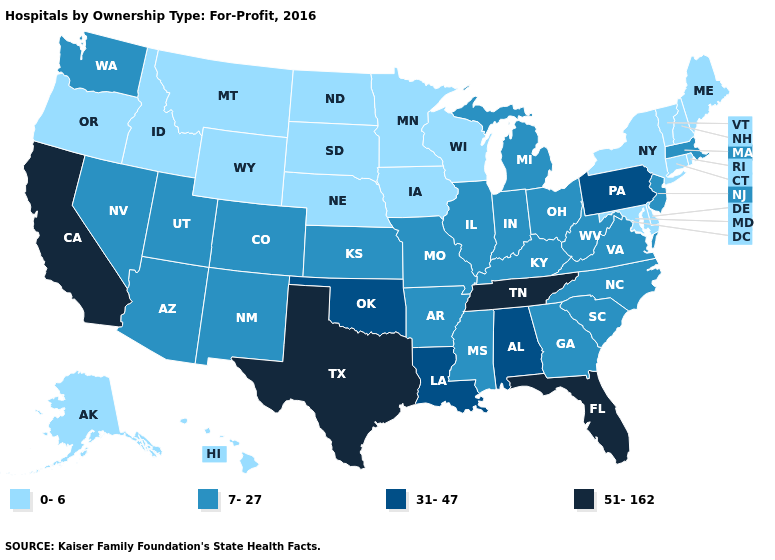Does the first symbol in the legend represent the smallest category?
Be succinct. Yes. Among the states that border Wyoming , does Colorado have the lowest value?
Concise answer only. No. What is the lowest value in the South?
Answer briefly. 0-6. What is the value of Mississippi?
Be succinct. 7-27. Which states have the lowest value in the USA?
Concise answer only. Alaska, Connecticut, Delaware, Hawaii, Idaho, Iowa, Maine, Maryland, Minnesota, Montana, Nebraska, New Hampshire, New York, North Dakota, Oregon, Rhode Island, South Dakota, Vermont, Wisconsin, Wyoming. Among the states that border Arkansas , does Mississippi have the highest value?
Keep it brief. No. What is the lowest value in the USA?
Concise answer only. 0-6. How many symbols are there in the legend?
Concise answer only. 4. What is the value of Connecticut?
Be succinct. 0-6. What is the value of Kansas?
Concise answer only. 7-27. Name the states that have a value in the range 7-27?
Keep it brief. Arizona, Arkansas, Colorado, Georgia, Illinois, Indiana, Kansas, Kentucky, Massachusetts, Michigan, Mississippi, Missouri, Nevada, New Jersey, New Mexico, North Carolina, Ohio, South Carolina, Utah, Virginia, Washington, West Virginia. What is the lowest value in the USA?
Keep it brief. 0-6. What is the value of Ohio?
Answer briefly. 7-27. Name the states that have a value in the range 0-6?
Concise answer only. Alaska, Connecticut, Delaware, Hawaii, Idaho, Iowa, Maine, Maryland, Minnesota, Montana, Nebraska, New Hampshire, New York, North Dakota, Oregon, Rhode Island, South Dakota, Vermont, Wisconsin, Wyoming. 